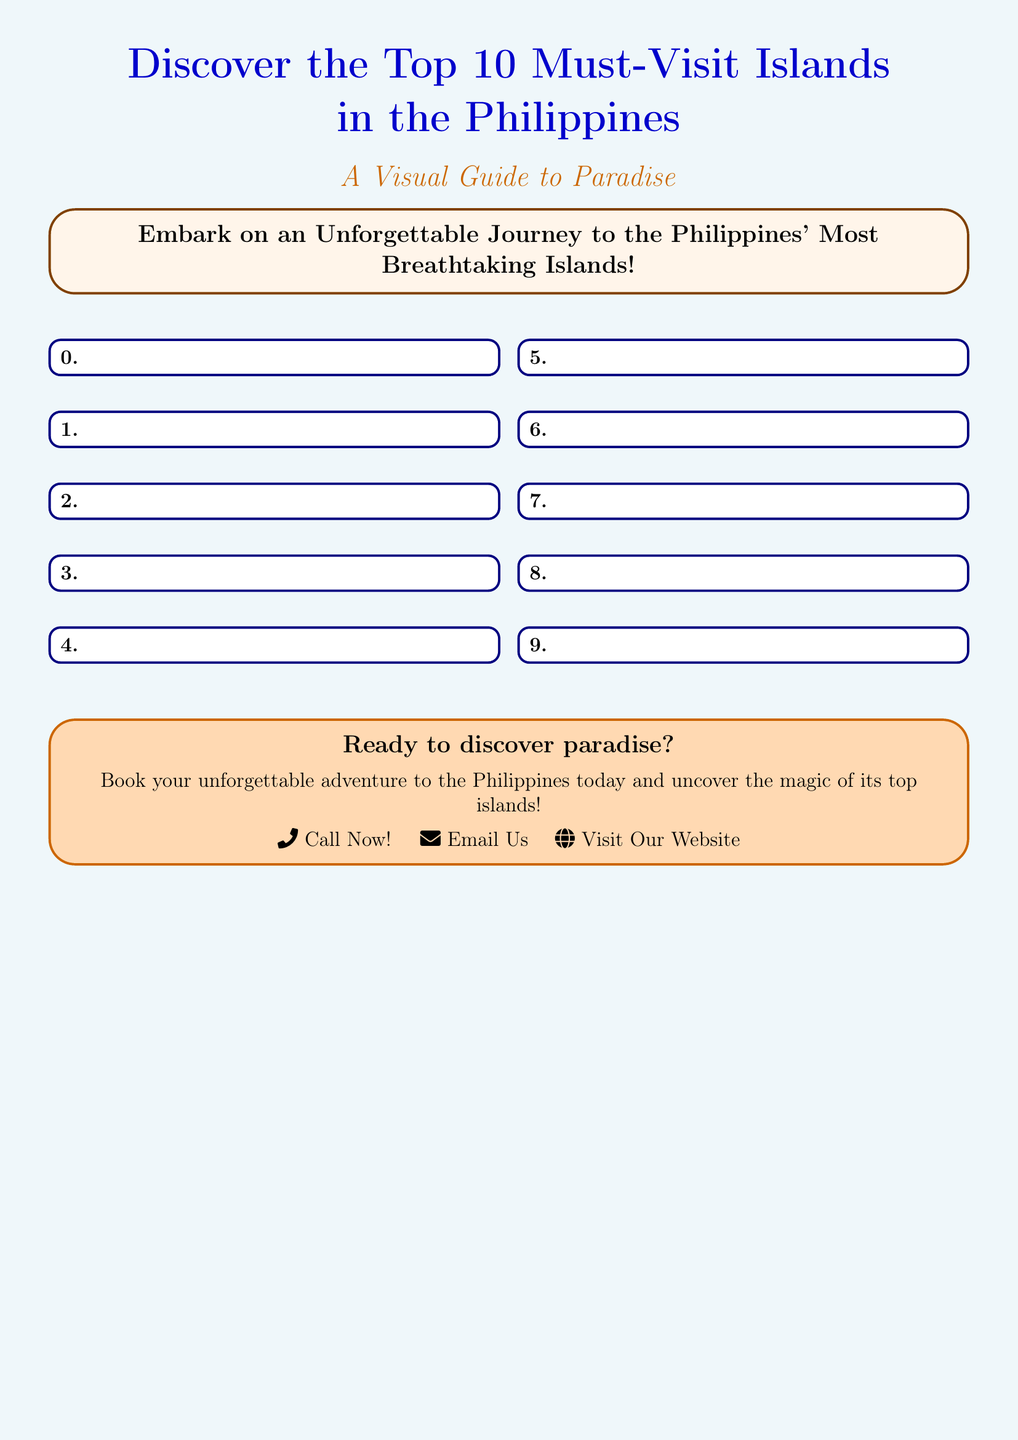what is the title of the document? The title is presented prominently at the top of the document, indicating the main subject.
Answer: Discover the Top 10 Must-Visit Islands what is the subtitle of the document? The subtitle provides additional context for the main title and guides the reader on what to expect.
Answer: A Visual Guide to Paradise how many islands are featured in the document? The number of islands is explicitly mentioned in the title, which is a key focus of the document.
Answer: 10 what color is the background of the document? The background color of the document is a specific shade that sets the overall tone.
Answer: beachblue what type of journey does the document promote? The document encourages readers to engage in a specific type of experience related to travel.
Answer: Unforgettable Journey what is the call to action at the end of the document? The conclusion of the document encourages action and provides contact options for the reader.
Answer: Book your unforgettable adventure what type of layout does the document use? The structure or design of the document is essential to understand how information is presented.
Answer: Multicolumn layout what is the mood conveyed by the color sandyellow? The color selection contributes to the overall feeling and theme communicated in the document.
Answer: Vibrant and inviting what visual style is used in the design? The aesthetic elements give insight into the overall style intended for the reader.
Answer: Recreational and tropical 